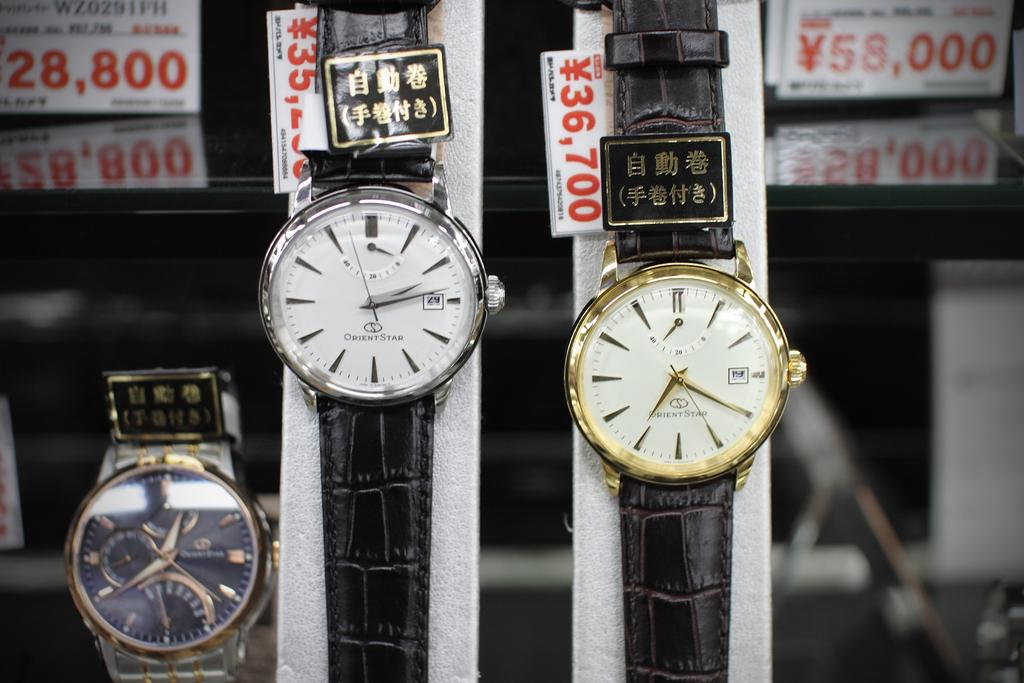<image>
Share a concise interpretation of the image provided. An Orient Star watch with a gold edge sells for 36,700. 